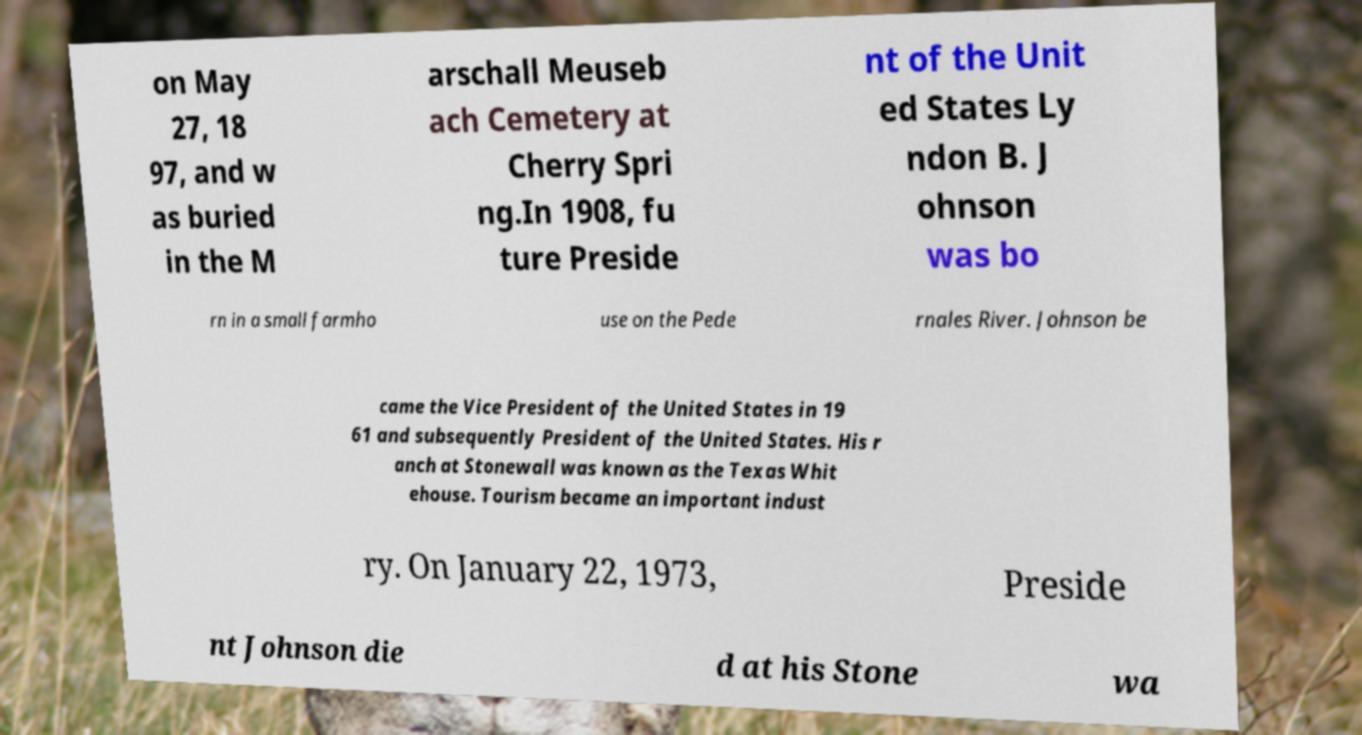There's text embedded in this image that I need extracted. Can you transcribe it verbatim? on May 27, 18 97, and w as buried in the M arschall Meuseb ach Cemetery at Cherry Spri ng.In 1908, fu ture Preside nt of the Unit ed States Ly ndon B. J ohnson was bo rn in a small farmho use on the Pede rnales River. Johnson be came the Vice President of the United States in 19 61 and subsequently President of the United States. His r anch at Stonewall was known as the Texas Whit ehouse. Tourism became an important indust ry. On January 22, 1973, Preside nt Johnson die d at his Stone wa 